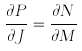<formula> <loc_0><loc_0><loc_500><loc_500>\frac { \partial P } { \partial J } = \frac { \partial N } { \partial M }</formula> 